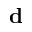<formula> <loc_0><loc_0><loc_500><loc_500>d</formula> 